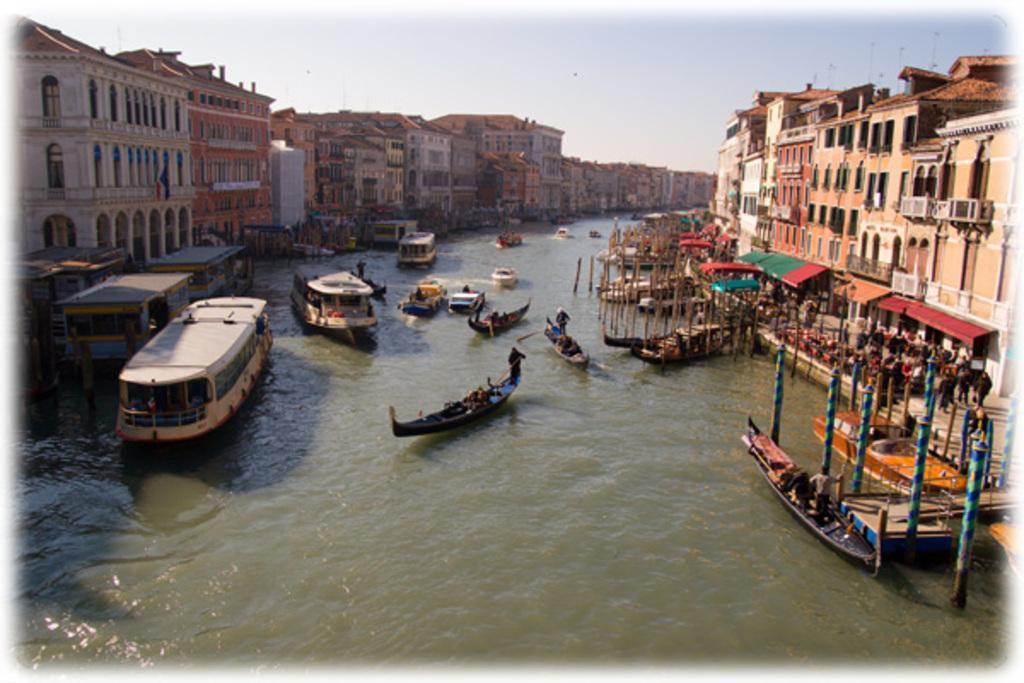Could you give a brief overview of what you see in this image? In this image, at the bottom there are water, boats, poles, people, tents. In the middle there are buildings, sky. 